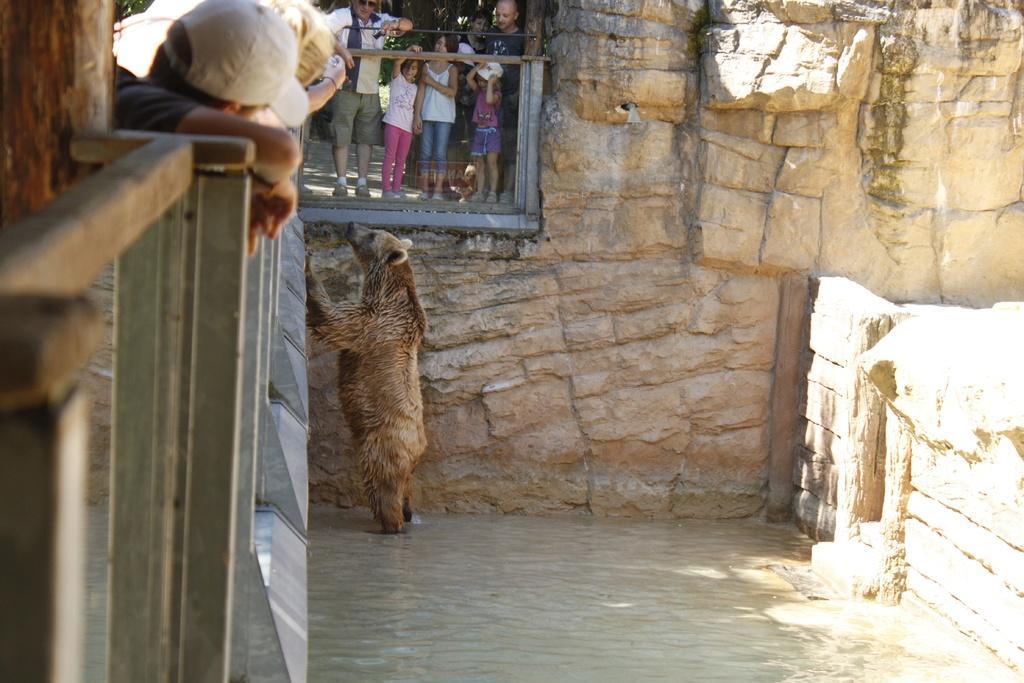In one or two sentences, can you explain what this image depicts? There is one bear is present as we can see in the middle of this image,and there is a wall in the background. There are some persons standing at the top of this image. There is a fencing on the left side of this image. 